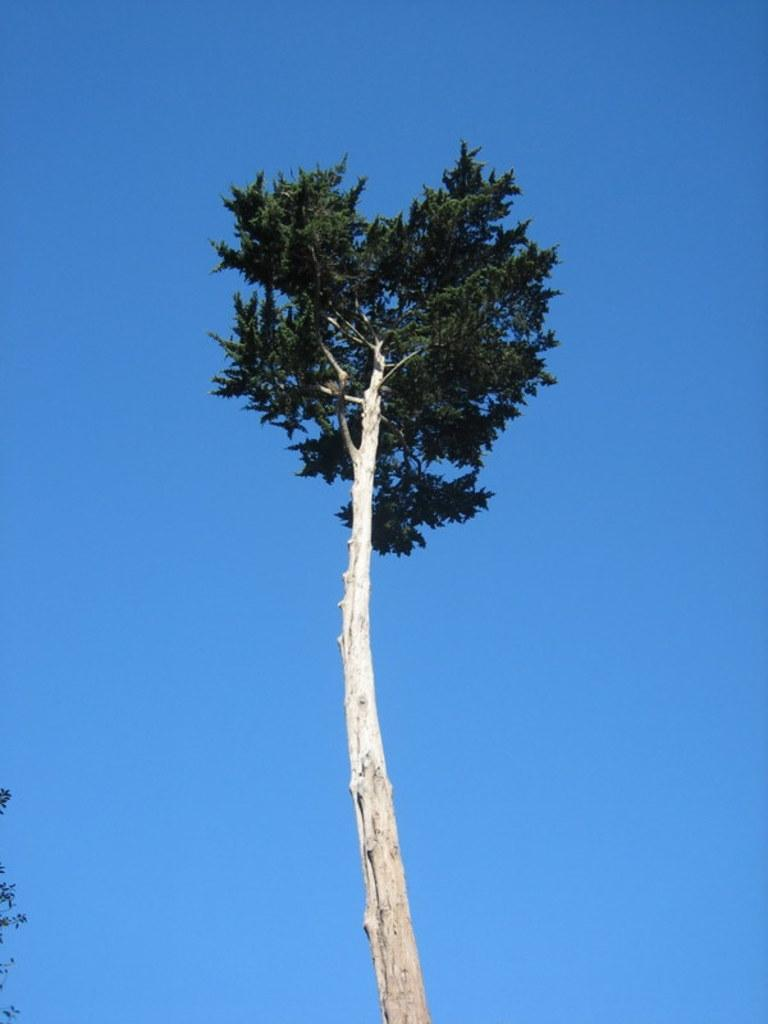What is the main object in the image? There is a tree in the image. What can be seen in the background of the image? The sky is visible in the background of the image. What color is the sky in the image? The sky is blue in color. Where are the leaves located in the image? A few leaves are visible in the bottom left of the image. What type of quartz can be seen on the secretary's desk in the image? There is no secretary or desk present in the image. 